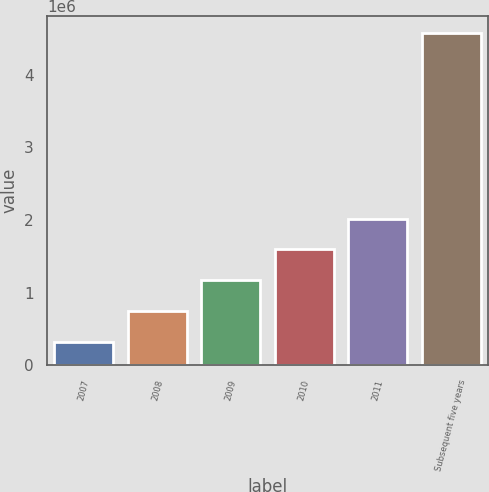<chart> <loc_0><loc_0><loc_500><loc_500><bar_chart><fcel>2007<fcel>2008<fcel>2009<fcel>2010<fcel>2011<fcel>Subsequent five years<nl><fcel>315000<fcel>741600<fcel>1.1682e+06<fcel>1.5948e+06<fcel>2.0214e+06<fcel>4.581e+06<nl></chart> 